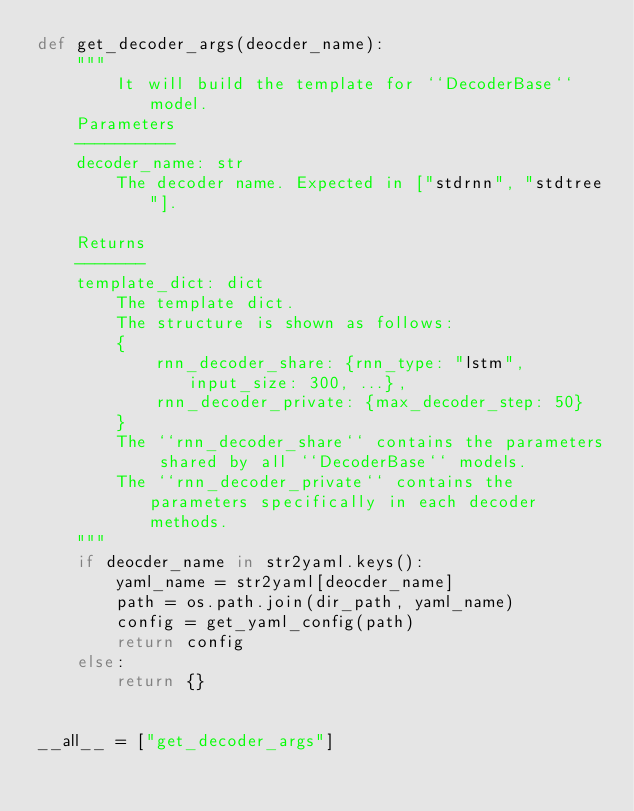Convert code to text. <code><loc_0><loc_0><loc_500><loc_500><_Python_>def get_decoder_args(deocder_name):
    """
        It will build the template for ``DecoderBase`` model.
    Parameters
    ----------
    decoder_name: str
        The decoder name. Expected in ["stdrnn", "stdtree"].

    Returns
    -------
    template_dict: dict
        The template dict.
        The structure is shown as follows:
        {
            rnn_decoder_share: {rnn_type: "lstm", input_size: 300, ...},
            rnn_decoder_private: {max_decoder_step: 50}
        }
        The ``rnn_decoder_share`` contains the parameters shared by all ``DecoderBase`` models.
        The ``rnn_decoder_private`` contains the parameters specifically in each decoder methods.
    """
    if deocder_name in str2yaml.keys():
        yaml_name = str2yaml[deocder_name]
        path = os.path.join(dir_path, yaml_name)
        config = get_yaml_config(path)
        return config
    else:
        return {}


__all__ = ["get_decoder_args"]
</code> 